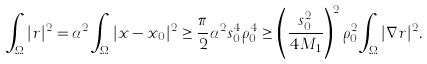Convert formula to latex. <formula><loc_0><loc_0><loc_500><loc_500>\int _ { \Omega } | r | ^ { 2 } = \alpha ^ { 2 } \int _ { \Omega } | x - x _ { 0 } | ^ { 2 } \geq \frac { \pi } { 2 } \alpha ^ { 2 } s _ { 0 } ^ { 4 } \rho _ { 0 } ^ { 4 } \geq \left ( \frac { s _ { 0 } ^ { 2 } } { 4 M _ { 1 } } \right ) ^ { 2 } \rho _ { 0 } ^ { 2 } \int _ { \Omega } | \nabla r | ^ { 2 } .</formula> 